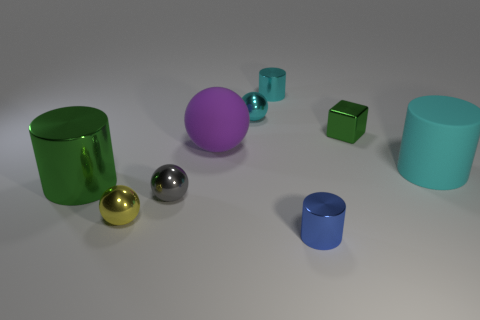What material is the small object that is both in front of the cyan ball and behind the big cyan matte thing?
Provide a succinct answer. Metal. What number of other things are made of the same material as the big green object?
Your answer should be very brief. 6. What number of small shiny things are the same color as the big metallic object?
Your answer should be compact. 1. There is a ball that is behind the green thing behind the big green shiny cylinder in front of the tiny cyan metal sphere; how big is it?
Keep it short and to the point. Small. What number of rubber objects are small spheres or large blue cylinders?
Your response must be concise. 0. Does the tiny yellow object have the same shape as the green object that is behind the green metal cylinder?
Your response must be concise. No. Is the number of tiny green blocks that are in front of the blue metallic thing greater than the number of blocks in front of the matte cylinder?
Provide a succinct answer. No. Are there any other things of the same color as the big metallic cylinder?
Your response must be concise. Yes. Is there a cylinder that is left of the tiny metallic cylinder that is behind the metal ball on the right side of the small gray shiny ball?
Offer a very short reply. Yes. There is a cyan object that is right of the tiny green object; does it have the same shape as the big metal object?
Make the answer very short. Yes. 